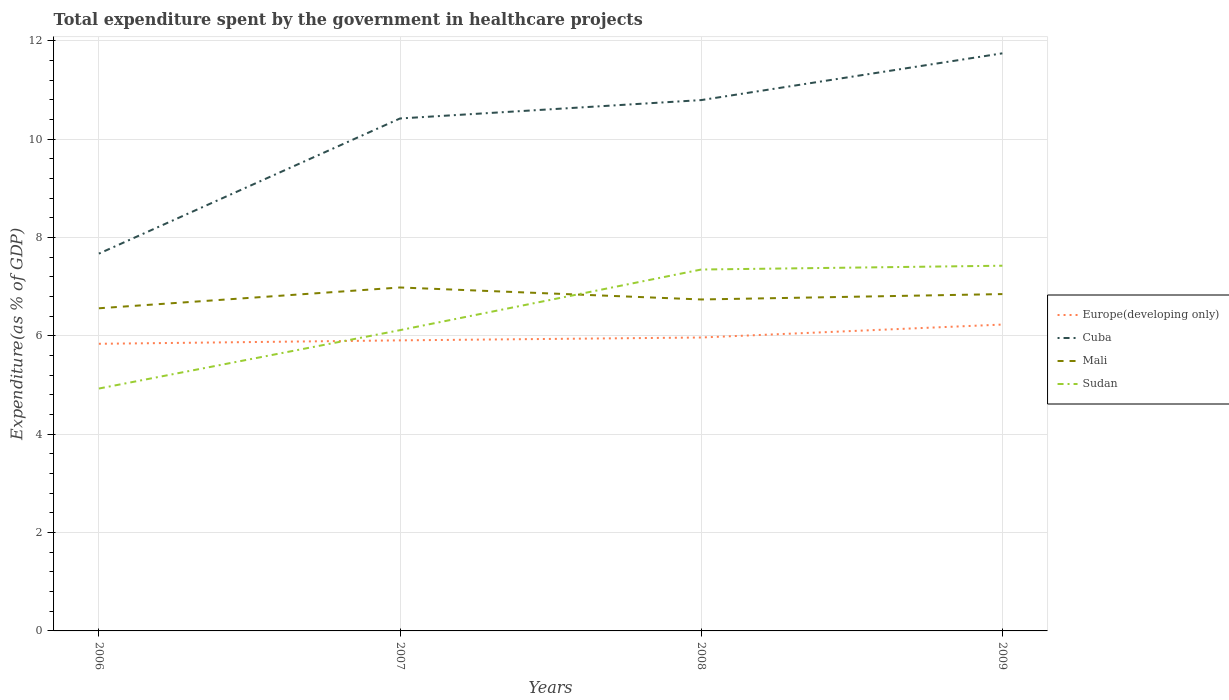Across all years, what is the maximum total expenditure spent by the government in healthcare projects in Mali?
Keep it short and to the point. 6.56. What is the total total expenditure spent by the government in healthcare projects in Sudan in the graph?
Your response must be concise. -1.31. What is the difference between the highest and the second highest total expenditure spent by the government in healthcare projects in Sudan?
Keep it short and to the point. 2.5. What is the difference between the highest and the lowest total expenditure spent by the government in healthcare projects in Mali?
Keep it short and to the point. 2. How many years are there in the graph?
Provide a succinct answer. 4. What is the difference between two consecutive major ticks on the Y-axis?
Your answer should be compact. 2. Are the values on the major ticks of Y-axis written in scientific E-notation?
Provide a short and direct response. No. Does the graph contain any zero values?
Provide a short and direct response. No. Where does the legend appear in the graph?
Your answer should be very brief. Center right. How many legend labels are there?
Your response must be concise. 4. How are the legend labels stacked?
Ensure brevity in your answer.  Vertical. What is the title of the graph?
Ensure brevity in your answer.  Total expenditure spent by the government in healthcare projects. What is the label or title of the X-axis?
Make the answer very short. Years. What is the label or title of the Y-axis?
Provide a short and direct response. Expenditure(as % of GDP). What is the Expenditure(as % of GDP) of Europe(developing only) in 2006?
Your answer should be compact. 5.84. What is the Expenditure(as % of GDP) in Cuba in 2006?
Ensure brevity in your answer.  7.67. What is the Expenditure(as % of GDP) of Mali in 2006?
Provide a short and direct response. 6.56. What is the Expenditure(as % of GDP) of Sudan in 2006?
Provide a succinct answer. 4.93. What is the Expenditure(as % of GDP) of Europe(developing only) in 2007?
Your answer should be very brief. 5.91. What is the Expenditure(as % of GDP) of Cuba in 2007?
Your answer should be compact. 10.42. What is the Expenditure(as % of GDP) in Mali in 2007?
Provide a short and direct response. 6.98. What is the Expenditure(as % of GDP) in Sudan in 2007?
Make the answer very short. 6.12. What is the Expenditure(as % of GDP) of Europe(developing only) in 2008?
Offer a terse response. 5.97. What is the Expenditure(as % of GDP) in Cuba in 2008?
Provide a succinct answer. 10.79. What is the Expenditure(as % of GDP) in Mali in 2008?
Give a very brief answer. 6.74. What is the Expenditure(as % of GDP) of Sudan in 2008?
Give a very brief answer. 7.35. What is the Expenditure(as % of GDP) of Europe(developing only) in 2009?
Provide a short and direct response. 6.23. What is the Expenditure(as % of GDP) of Cuba in 2009?
Offer a very short reply. 11.74. What is the Expenditure(as % of GDP) in Mali in 2009?
Provide a short and direct response. 6.85. What is the Expenditure(as % of GDP) in Sudan in 2009?
Your response must be concise. 7.43. Across all years, what is the maximum Expenditure(as % of GDP) in Europe(developing only)?
Give a very brief answer. 6.23. Across all years, what is the maximum Expenditure(as % of GDP) of Cuba?
Offer a terse response. 11.74. Across all years, what is the maximum Expenditure(as % of GDP) of Mali?
Make the answer very short. 6.98. Across all years, what is the maximum Expenditure(as % of GDP) of Sudan?
Offer a terse response. 7.43. Across all years, what is the minimum Expenditure(as % of GDP) in Europe(developing only)?
Keep it short and to the point. 5.84. Across all years, what is the minimum Expenditure(as % of GDP) in Cuba?
Your response must be concise. 7.67. Across all years, what is the minimum Expenditure(as % of GDP) of Mali?
Your response must be concise. 6.56. Across all years, what is the minimum Expenditure(as % of GDP) in Sudan?
Offer a terse response. 4.93. What is the total Expenditure(as % of GDP) of Europe(developing only) in the graph?
Your answer should be compact. 23.94. What is the total Expenditure(as % of GDP) of Cuba in the graph?
Keep it short and to the point. 40.63. What is the total Expenditure(as % of GDP) of Mali in the graph?
Give a very brief answer. 27.13. What is the total Expenditure(as % of GDP) of Sudan in the graph?
Give a very brief answer. 25.82. What is the difference between the Expenditure(as % of GDP) of Europe(developing only) in 2006 and that in 2007?
Offer a terse response. -0.07. What is the difference between the Expenditure(as % of GDP) in Cuba in 2006 and that in 2007?
Your response must be concise. -2.75. What is the difference between the Expenditure(as % of GDP) of Mali in 2006 and that in 2007?
Ensure brevity in your answer.  -0.42. What is the difference between the Expenditure(as % of GDP) in Sudan in 2006 and that in 2007?
Offer a very short reply. -1.19. What is the difference between the Expenditure(as % of GDP) of Europe(developing only) in 2006 and that in 2008?
Provide a short and direct response. -0.13. What is the difference between the Expenditure(as % of GDP) in Cuba in 2006 and that in 2008?
Ensure brevity in your answer.  -3.12. What is the difference between the Expenditure(as % of GDP) in Mali in 2006 and that in 2008?
Offer a terse response. -0.18. What is the difference between the Expenditure(as % of GDP) of Sudan in 2006 and that in 2008?
Make the answer very short. -2.42. What is the difference between the Expenditure(as % of GDP) in Europe(developing only) in 2006 and that in 2009?
Your response must be concise. -0.39. What is the difference between the Expenditure(as % of GDP) in Cuba in 2006 and that in 2009?
Offer a terse response. -4.07. What is the difference between the Expenditure(as % of GDP) of Mali in 2006 and that in 2009?
Provide a succinct answer. -0.29. What is the difference between the Expenditure(as % of GDP) of Sudan in 2006 and that in 2009?
Your answer should be compact. -2.5. What is the difference between the Expenditure(as % of GDP) in Europe(developing only) in 2007 and that in 2008?
Make the answer very short. -0.06. What is the difference between the Expenditure(as % of GDP) in Cuba in 2007 and that in 2008?
Your answer should be compact. -0.37. What is the difference between the Expenditure(as % of GDP) in Mali in 2007 and that in 2008?
Ensure brevity in your answer.  0.24. What is the difference between the Expenditure(as % of GDP) in Sudan in 2007 and that in 2008?
Ensure brevity in your answer.  -1.23. What is the difference between the Expenditure(as % of GDP) of Europe(developing only) in 2007 and that in 2009?
Keep it short and to the point. -0.32. What is the difference between the Expenditure(as % of GDP) in Cuba in 2007 and that in 2009?
Your answer should be very brief. -1.32. What is the difference between the Expenditure(as % of GDP) in Mali in 2007 and that in 2009?
Offer a terse response. 0.13. What is the difference between the Expenditure(as % of GDP) in Sudan in 2007 and that in 2009?
Provide a short and direct response. -1.31. What is the difference between the Expenditure(as % of GDP) in Europe(developing only) in 2008 and that in 2009?
Ensure brevity in your answer.  -0.26. What is the difference between the Expenditure(as % of GDP) of Cuba in 2008 and that in 2009?
Provide a succinct answer. -0.95. What is the difference between the Expenditure(as % of GDP) of Mali in 2008 and that in 2009?
Keep it short and to the point. -0.11. What is the difference between the Expenditure(as % of GDP) of Sudan in 2008 and that in 2009?
Provide a short and direct response. -0.08. What is the difference between the Expenditure(as % of GDP) in Europe(developing only) in 2006 and the Expenditure(as % of GDP) in Cuba in 2007?
Ensure brevity in your answer.  -4.58. What is the difference between the Expenditure(as % of GDP) of Europe(developing only) in 2006 and the Expenditure(as % of GDP) of Mali in 2007?
Make the answer very short. -1.15. What is the difference between the Expenditure(as % of GDP) in Europe(developing only) in 2006 and the Expenditure(as % of GDP) in Sudan in 2007?
Your answer should be compact. -0.28. What is the difference between the Expenditure(as % of GDP) in Cuba in 2006 and the Expenditure(as % of GDP) in Mali in 2007?
Provide a succinct answer. 0.69. What is the difference between the Expenditure(as % of GDP) of Cuba in 2006 and the Expenditure(as % of GDP) of Sudan in 2007?
Provide a short and direct response. 1.56. What is the difference between the Expenditure(as % of GDP) in Mali in 2006 and the Expenditure(as % of GDP) in Sudan in 2007?
Offer a very short reply. 0.44. What is the difference between the Expenditure(as % of GDP) of Europe(developing only) in 2006 and the Expenditure(as % of GDP) of Cuba in 2008?
Make the answer very short. -4.96. What is the difference between the Expenditure(as % of GDP) in Europe(developing only) in 2006 and the Expenditure(as % of GDP) in Mali in 2008?
Your answer should be very brief. -0.9. What is the difference between the Expenditure(as % of GDP) in Europe(developing only) in 2006 and the Expenditure(as % of GDP) in Sudan in 2008?
Offer a terse response. -1.51. What is the difference between the Expenditure(as % of GDP) of Cuba in 2006 and the Expenditure(as % of GDP) of Mali in 2008?
Provide a succinct answer. 0.93. What is the difference between the Expenditure(as % of GDP) in Cuba in 2006 and the Expenditure(as % of GDP) in Sudan in 2008?
Offer a terse response. 0.32. What is the difference between the Expenditure(as % of GDP) of Mali in 2006 and the Expenditure(as % of GDP) of Sudan in 2008?
Ensure brevity in your answer.  -0.79. What is the difference between the Expenditure(as % of GDP) in Europe(developing only) in 2006 and the Expenditure(as % of GDP) in Cuba in 2009?
Offer a very short reply. -5.91. What is the difference between the Expenditure(as % of GDP) of Europe(developing only) in 2006 and the Expenditure(as % of GDP) of Mali in 2009?
Provide a succinct answer. -1.01. What is the difference between the Expenditure(as % of GDP) of Europe(developing only) in 2006 and the Expenditure(as % of GDP) of Sudan in 2009?
Your answer should be compact. -1.59. What is the difference between the Expenditure(as % of GDP) of Cuba in 2006 and the Expenditure(as % of GDP) of Mali in 2009?
Your answer should be compact. 0.82. What is the difference between the Expenditure(as % of GDP) of Cuba in 2006 and the Expenditure(as % of GDP) of Sudan in 2009?
Give a very brief answer. 0.25. What is the difference between the Expenditure(as % of GDP) of Mali in 2006 and the Expenditure(as % of GDP) of Sudan in 2009?
Your response must be concise. -0.87. What is the difference between the Expenditure(as % of GDP) of Europe(developing only) in 2007 and the Expenditure(as % of GDP) of Cuba in 2008?
Offer a very short reply. -4.89. What is the difference between the Expenditure(as % of GDP) in Europe(developing only) in 2007 and the Expenditure(as % of GDP) in Mali in 2008?
Your answer should be very brief. -0.83. What is the difference between the Expenditure(as % of GDP) of Europe(developing only) in 2007 and the Expenditure(as % of GDP) of Sudan in 2008?
Ensure brevity in your answer.  -1.44. What is the difference between the Expenditure(as % of GDP) of Cuba in 2007 and the Expenditure(as % of GDP) of Mali in 2008?
Give a very brief answer. 3.68. What is the difference between the Expenditure(as % of GDP) of Cuba in 2007 and the Expenditure(as % of GDP) of Sudan in 2008?
Offer a very short reply. 3.07. What is the difference between the Expenditure(as % of GDP) of Mali in 2007 and the Expenditure(as % of GDP) of Sudan in 2008?
Make the answer very short. -0.36. What is the difference between the Expenditure(as % of GDP) of Europe(developing only) in 2007 and the Expenditure(as % of GDP) of Cuba in 2009?
Your response must be concise. -5.84. What is the difference between the Expenditure(as % of GDP) of Europe(developing only) in 2007 and the Expenditure(as % of GDP) of Mali in 2009?
Provide a short and direct response. -0.94. What is the difference between the Expenditure(as % of GDP) in Europe(developing only) in 2007 and the Expenditure(as % of GDP) in Sudan in 2009?
Provide a short and direct response. -1.52. What is the difference between the Expenditure(as % of GDP) in Cuba in 2007 and the Expenditure(as % of GDP) in Mali in 2009?
Provide a succinct answer. 3.57. What is the difference between the Expenditure(as % of GDP) of Cuba in 2007 and the Expenditure(as % of GDP) of Sudan in 2009?
Offer a very short reply. 2.99. What is the difference between the Expenditure(as % of GDP) of Mali in 2007 and the Expenditure(as % of GDP) of Sudan in 2009?
Offer a terse response. -0.44. What is the difference between the Expenditure(as % of GDP) of Europe(developing only) in 2008 and the Expenditure(as % of GDP) of Cuba in 2009?
Give a very brief answer. -5.78. What is the difference between the Expenditure(as % of GDP) in Europe(developing only) in 2008 and the Expenditure(as % of GDP) in Mali in 2009?
Offer a very short reply. -0.88. What is the difference between the Expenditure(as % of GDP) of Europe(developing only) in 2008 and the Expenditure(as % of GDP) of Sudan in 2009?
Provide a short and direct response. -1.46. What is the difference between the Expenditure(as % of GDP) in Cuba in 2008 and the Expenditure(as % of GDP) in Mali in 2009?
Give a very brief answer. 3.94. What is the difference between the Expenditure(as % of GDP) in Cuba in 2008 and the Expenditure(as % of GDP) in Sudan in 2009?
Your answer should be very brief. 3.37. What is the difference between the Expenditure(as % of GDP) of Mali in 2008 and the Expenditure(as % of GDP) of Sudan in 2009?
Keep it short and to the point. -0.69. What is the average Expenditure(as % of GDP) in Europe(developing only) per year?
Your answer should be very brief. 5.99. What is the average Expenditure(as % of GDP) in Cuba per year?
Your answer should be very brief. 10.16. What is the average Expenditure(as % of GDP) in Mali per year?
Provide a succinct answer. 6.78. What is the average Expenditure(as % of GDP) in Sudan per year?
Offer a very short reply. 6.45. In the year 2006, what is the difference between the Expenditure(as % of GDP) of Europe(developing only) and Expenditure(as % of GDP) of Cuba?
Offer a terse response. -1.83. In the year 2006, what is the difference between the Expenditure(as % of GDP) of Europe(developing only) and Expenditure(as % of GDP) of Mali?
Keep it short and to the point. -0.72. In the year 2006, what is the difference between the Expenditure(as % of GDP) in Europe(developing only) and Expenditure(as % of GDP) in Sudan?
Offer a very short reply. 0.91. In the year 2006, what is the difference between the Expenditure(as % of GDP) in Cuba and Expenditure(as % of GDP) in Mali?
Keep it short and to the point. 1.11. In the year 2006, what is the difference between the Expenditure(as % of GDP) in Cuba and Expenditure(as % of GDP) in Sudan?
Offer a very short reply. 2.74. In the year 2006, what is the difference between the Expenditure(as % of GDP) in Mali and Expenditure(as % of GDP) in Sudan?
Provide a succinct answer. 1.63. In the year 2007, what is the difference between the Expenditure(as % of GDP) in Europe(developing only) and Expenditure(as % of GDP) in Cuba?
Your answer should be compact. -4.51. In the year 2007, what is the difference between the Expenditure(as % of GDP) of Europe(developing only) and Expenditure(as % of GDP) of Mali?
Your answer should be compact. -1.08. In the year 2007, what is the difference between the Expenditure(as % of GDP) in Europe(developing only) and Expenditure(as % of GDP) in Sudan?
Provide a succinct answer. -0.21. In the year 2007, what is the difference between the Expenditure(as % of GDP) in Cuba and Expenditure(as % of GDP) in Mali?
Offer a very short reply. 3.44. In the year 2007, what is the difference between the Expenditure(as % of GDP) in Cuba and Expenditure(as % of GDP) in Sudan?
Your answer should be very brief. 4.3. In the year 2007, what is the difference between the Expenditure(as % of GDP) of Mali and Expenditure(as % of GDP) of Sudan?
Keep it short and to the point. 0.87. In the year 2008, what is the difference between the Expenditure(as % of GDP) of Europe(developing only) and Expenditure(as % of GDP) of Cuba?
Ensure brevity in your answer.  -4.83. In the year 2008, what is the difference between the Expenditure(as % of GDP) of Europe(developing only) and Expenditure(as % of GDP) of Mali?
Offer a very short reply. -0.77. In the year 2008, what is the difference between the Expenditure(as % of GDP) in Europe(developing only) and Expenditure(as % of GDP) in Sudan?
Provide a succinct answer. -1.38. In the year 2008, what is the difference between the Expenditure(as % of GDP) of Cuba and Expenditure(as % of GDP) of Mali?
Provide a short and direct response. 4.05. In the year 2008, what is the difference between the Expenditure(as % of GDP) in Cuba and Expenditure(as % of GDP) in Sudan?
Your response must be concise. 3.45. In the year 2008, what is the difference between the Expenditure(as % of GDP) of Mali and Expenditure(as % of GDP) of Sudan?
Give a very brief answer. -0.61. In the year 2009, what is the difference between the Expenditure(as % of GDP) in Europe(developing only) and Expenditure(as % of GDP) in Cuba?
Your answer should be very brief. -5.51. In the year 2009, what is the difference between the Expenditure(as % of GDP) of Europe(developing only) and Expenditure(as % of GDP) of Mali?
Offer a very short reply. -0.62. In the year 2009, what is the difference between the Expenditure(as % of GDP) of Europe(developing only) and Expenditure(as % of GDP) of Sudan?
Your answer should be very brief. -1.2. In the year 2009, what is the difference between the Expenditure(as % of GDP) in Cuba and Expenditure(as % of GDP) in Mali?
Provide a short and direct response. 4.89. In the year 2009, what is the difference between the Expenditure(as % of GDP) in Cuba and Expenditure(as % of GDP) in Sudan?
Offer a terse response. 4.32. In the year 2009, what is the difference between the Expenditure(as % of GDP) of Mali and Expenditure(as % of GDP) of Sudan?
Provide a short and direct response. -0.58. What is the ratio of the Expenditure(as % of GDP) of Europe(developing only) in 2006 to that in 2007?
Keep it short and to the point. 0.99. What is the ratio of the Expenditure(as % of GDP) in Cuba in 2006 to that in 2007?
Offer a terse response. 0.74. What is the ratio of the Expenditure(as % of GDP) of Mali in 2006 to that in 2007?
Keep it short and to the point. 0.94. What is the ratio of the Expenditure(as % of GDP) of Sudan in 2006 to that in 2007?
Your answer should be very brief. 0.81. What is the ratio of the Expenditure(as % of GDP) of Europe(developing only) in 2006 to that in 2008?
Keep it short and to the point. 0.98. What is the ratio of the Expenditure(as % of GDP) of Cuba in 2006 to that in 2008?
Provide a succinct answer. 0.71. What is the ratio of the Expenditure(as % of GDP) of Mali in 2006 to that in 2008?
Provide a short and direct response. 0.97. What is the ratio of the Expenditure(as % of GDP) of Sudan in 2006 to that in 2008?
Keep it short and to the point. 0.67. What is the ratio of the Expenditure(as % of GDP) of Europe(developing only) in 2006 to that in 2009?
Ensure brevity in your answer.  0.94. What is the ratio of the Expenditure(as % of GDP) in Cuba in 2006 to that in 2009?
Provide a succinct answer. 0.65. What is the ratio of the Expenditure(as % of GDP) in Mali in 2006 to that in 2009?
Provide a short and direct response. 0.96. What is the ratio of the Expenditure(as % of GDP) of Sudan in 2006 to that in 2009?
Your answer should be very brief. 0.66. What is the ratio of the Expenditure(as % of GDP) of Europe(developing only) in 2007 to that in 2008?
Keep it short and to the point. 0.99. What is the ratio of the Expenditure(as % of GDP) of Cuba in 2007 to that in 2008?
Make the answer very short. 0.97. What is the ratio of the Expenditure(as % of GDP) in Mali in 2007 to that in 2008?
Give a very brief answer. 1.04. What is the ratio of the Expenditure(as % of GDP) in Sudan in 2007 to that in 2008?
Offer a terse response. 0.83. What is the ratio of the Expenditure(as % of GDP) of Europe(developing only) in 2007 to that in 2009?
Give a very brief answer. 0.95. What is the ratio of the Expenditure(as % of GDP) of Cuba in 2007 to that in 2009?
Offer a terse response. 0.89. What is the ratio of the Expenditure(as % of GDP) in Mali in 2007 to that in 2009?
Provide a short and direct response. 1.02. What is the ratio of the Expenditure(as % of GDP) in Sudan in 2007 to that in 2009?
Your response must be concise. 0.82. What is the ratio of the Expenditure(as % of GDP) of Europe(developing only) in 2008 to that in 2009?
Provide a short and direct response. 0.96. What is the ratio of the Expenditure(as % of GDP) in Cuba in 2008 to that in 2009?
Offer a terse response. 0.92. What is the ratio of the Expenditure(as % of GDP) of Sudan in 2008 to that in 2009?
Offer a terse response. 0.99. What is the difference between the highest and the second highest Expenditure(as % of GDP) of Europe(developing only)?
Offer a very short reply. 0.26. What is the difference between the highest and the second highest Expenditure(as % of GDP) in Cuba?
Your answer should be compact. 0.95. What is the difference between the highest and the second highest Expenditure(as % of GDP) of Mali?
Your response must be concise. 0.13. What is the difference between the highest and the second highest Expenditure(as % of GDP) of Sudan?
Give a very brief answer. 0.08. What is the difference between the highest and the lowest Expenditure(as % of GDP) in Europe(developing only)?
Offer a very short reply. 0.39. What is the difference between the highest and the lowest Expenditure(as % of GDP) of Cuba?
Offer a terse response. 4.07. What is the difference between the highest and the lowest Expenditure(as % of GDP) in Mali?
Provide a short and direct response. 0.42. What is the difference between the highest and the lowest Expenditure(as % of GDP) in Sudan?
Provide a succinct answer. 2.5. 